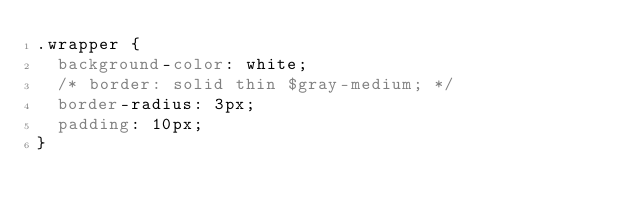Convert code to text. <code><loc_0><loc_0><loc_500><loc_500><_CSS_>.wrapper {
  background-color: white;
  /* border: solid thin $gray-medium; */
  border-radius: 3px;
  padding: 10px;
}</code> 